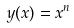Convert formula to latex. <formula><loc_0><loc_0><loc_500><loc_500>y ( x ) = x ^ { n }</formula> 